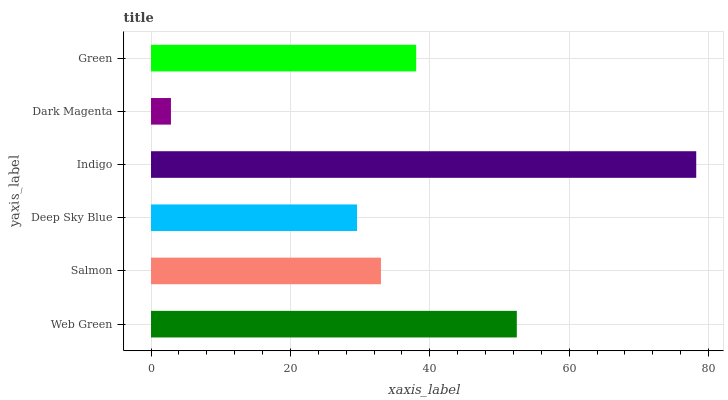Is Dark Magenta the minimum?
Answer yes or no. Yes. Is Indigo the maximum?
Answer yes or no. Yes. Is Salmon the minimum?
Answer yes or no. No. Is Salmon the maximum?
Answer yes or no. No. Is Web Green greater than Salmon?
Answer yes or no. Yes. Is Salmon less than Web Green?
Answer yes or no. Yes. Is Salmon greater than Web Green?
Answer yes or no. No. Is Web Green less than Salmon?
Answer yes or no. No. Is Green the high median?
Answer yes or no. Yes. Is Salmon the low median?
Answer yes or no. Yes. Is Dark Magenta the high median?
Answer yes or no. No. Is Dark Magenta the low median?
Answer yes or no. No. 